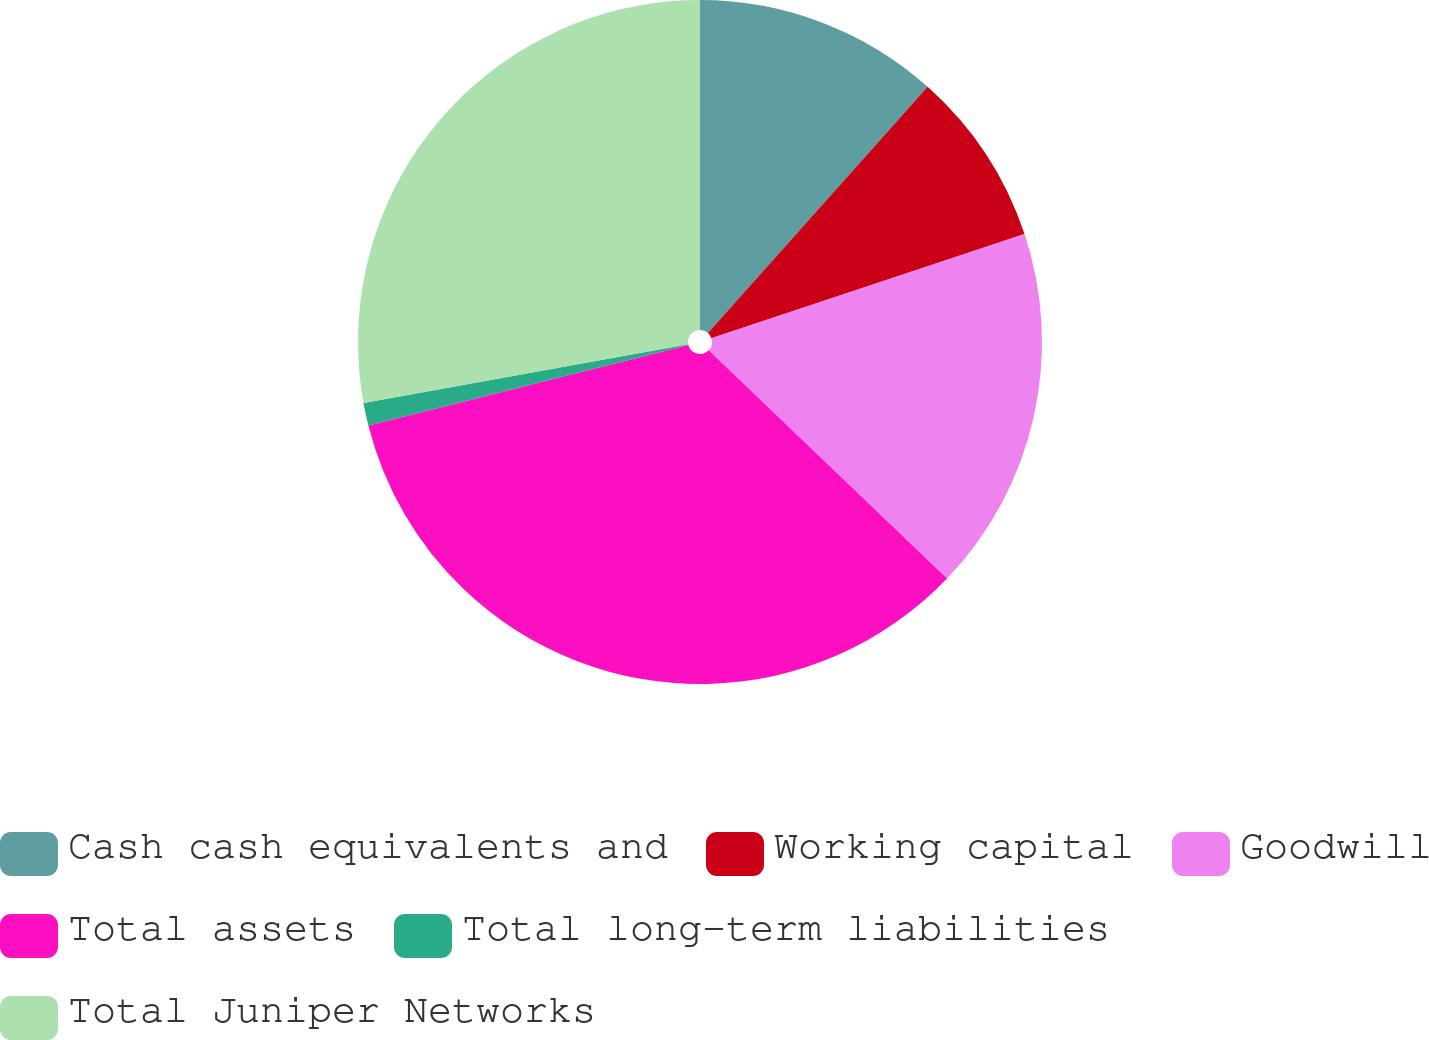<chart> <loc_0><loc_0><loc_500><loc_500><pie_chart><fcel>Cash cash equivalents and<fcel>Working capital<fcel>Goodwill<fcel>Total assets<fcel>Total long-term liabilities<fcel>Total Juniper Networks<nl><fcel>11.59%<fcel>8.3%<fcel>17.26%<fcel>33.92%<fcel>1.08%<fcel>27.85%<nl></chart> 